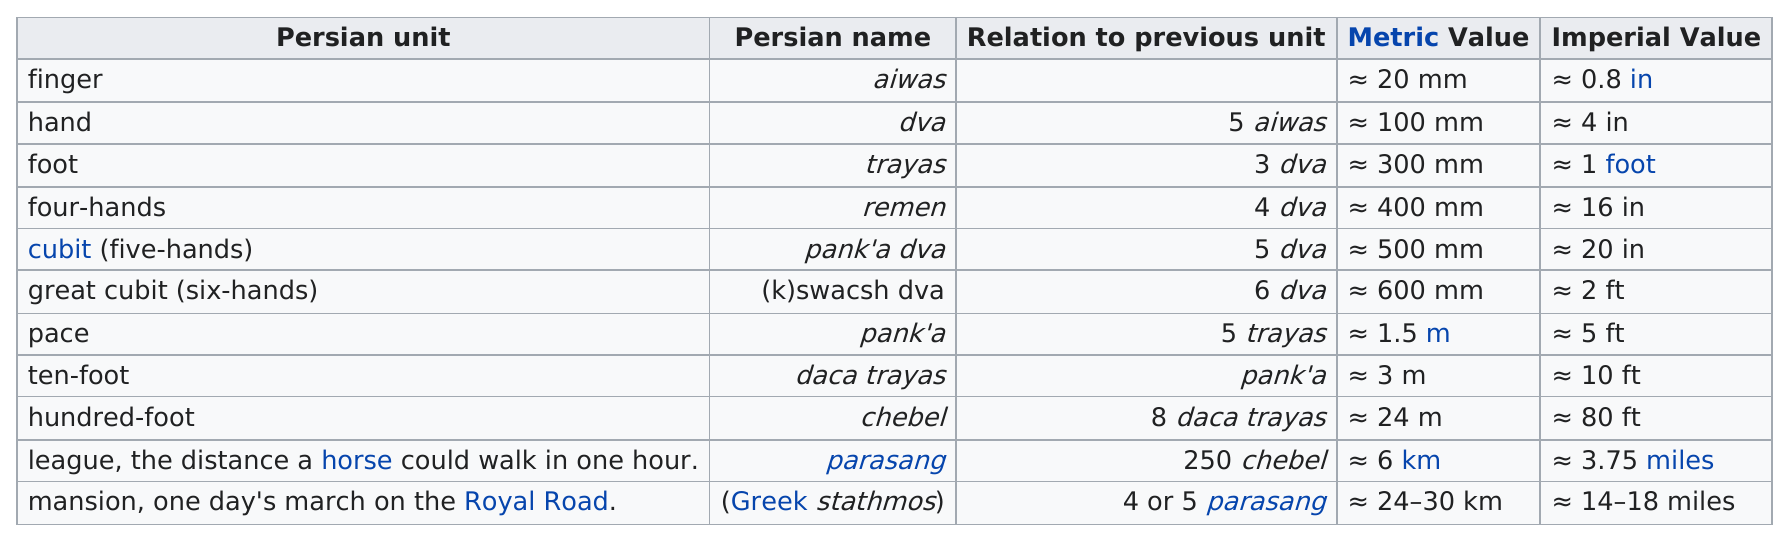Point out several critical features in this image. Which is longer, a pace or a great cubit?" is a question asking for an explanation or comparison between two lengths. In a comparison between two lengths, a league had a higher metric value than a great cubit. The Persian unit that is at least five feet in length is the pace. The unit that is listed first is the finger. The length of a league in imperial units is 3.75 miles. 